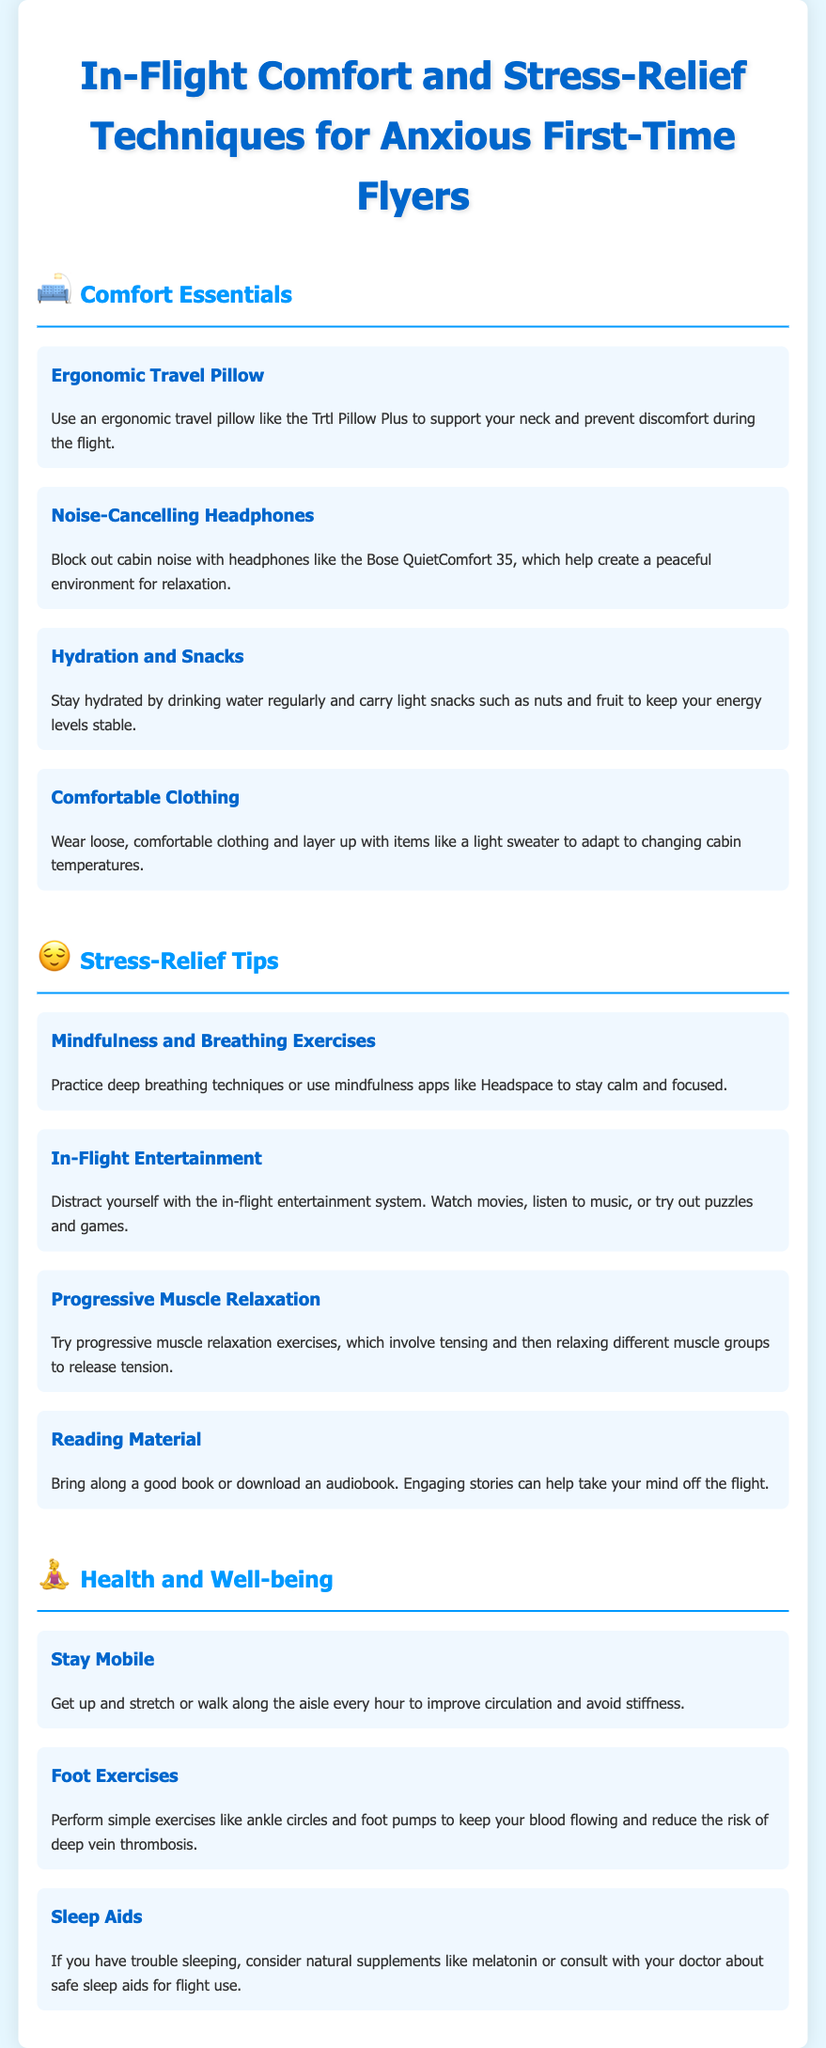what is a recommended ergonomic travel pillow? The document mentions the Trtl Pillow Plus as a recommended ergonomic travel pillow.
Answer: Trtl Pillow Plus what is a suggested type of headphones for blocking noise? The document recommends noise-cancelling headphones like the Bose QuietComfort 35 for blocking cabin noise.
Answer: Bose QuietComfort 35 how often should you get up and stretch during the flight? The document suggests getting up and stretching every hour to improve circulation.
Answer: every hour what relaxation technique involves tensing and relaxing muscle groups? The document refers to progressive muscle relaxation as a technique that involves tensing and relaxing different muscle groups.
Answer: progressive muscle relaxation what should you do to stay hydrated during the flight? The document advises drinking water regularly to stay hydrated.
Answer: drinking water which app is suggested for mindfulness practices? The document suggests using mindfulness apps like Headspace for calming techniques.
Answer: Headspace what type of clothing is recommended for in-flight comfort? The document recommends wearing loose, comfortable clothing for in-flight comfort.
Answer: loose, comfortable clothing what should you bring for in-flight entertainment? The document suggests bringing along a good book or downloading an audiobook for entertainment.
Answer: good book or audiobook 